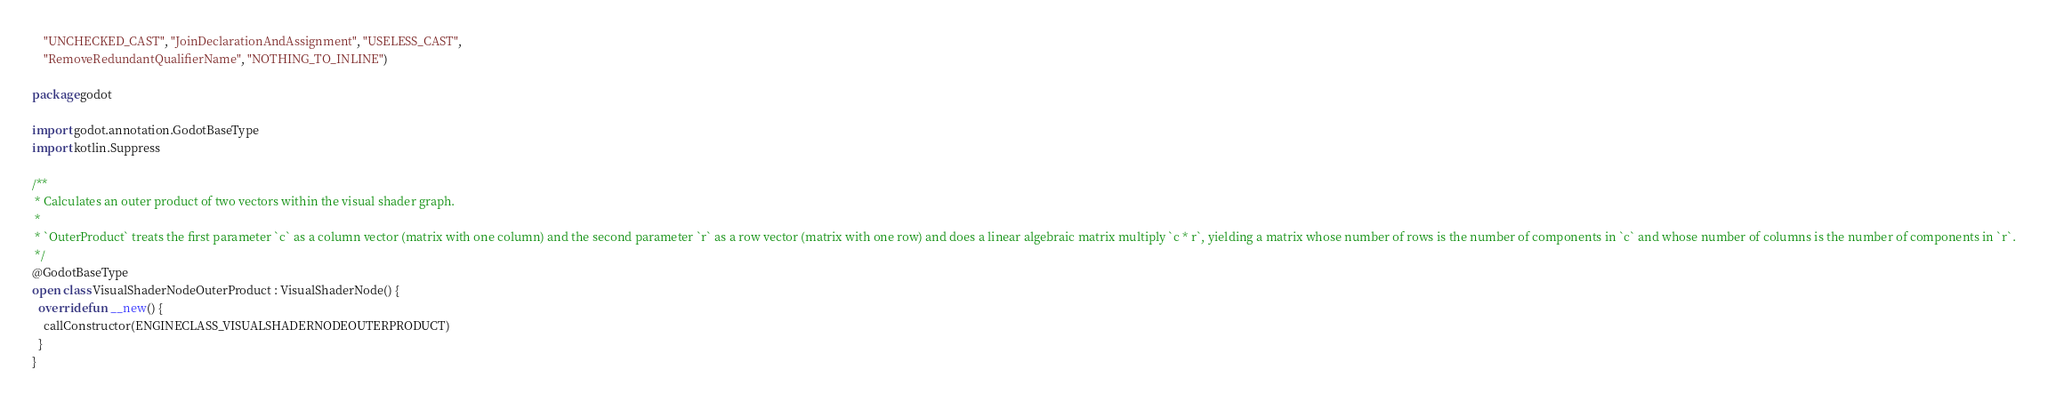Convert code to text. <code><loc_0><loc_0><loc_500><loc_500><_Kotlin_>    "UNCHECKED_CAST", "JoinDeclarationAndAssignment", "USELESS_CAST",
    "RemoveRedundantQualifierName", "NOTHING_TO_INLINE")

package godot

import godot.annotation.GodotBaseType
import kotlin.Suppress

/**
 * Calculates an outer product of two vectors within the visual shader graph.
 *
 * `OuterProduct` treats the first parameter `c` as a column vector (matrix with one column) and the second parameter `r` as a row vector (matrix with one row) and does a linear algebraic matrix multiply `c * r`, yielding a matrix whose number of rows is the number of components in `c` and whose number of columns is the number of components in `r`.
 */
@GodotBaseType
open class VisualShaderNodeOuterProduct : VisualShaderNode() {
  override fun __new() {
    callConstructor(ENGINECLASS_VISUALSHADERNODEOUTERPRODUCT)
  }
}
</code> 